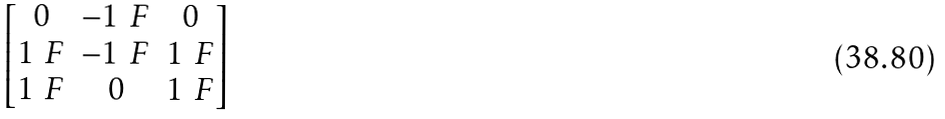Convert formula to latex. <formula><loc_0><loc_0><loc_500><loc_500>\begin{bmatrix} 0 & - 1 _ { \ } F & 0 \\ 1 _ { \ } F & - 1 _ { \ } F & 1 _ { \ } F \\ 1 _ { \ } F & 0 & 1 _ { \ } F \end{bmatrix}</formula> 